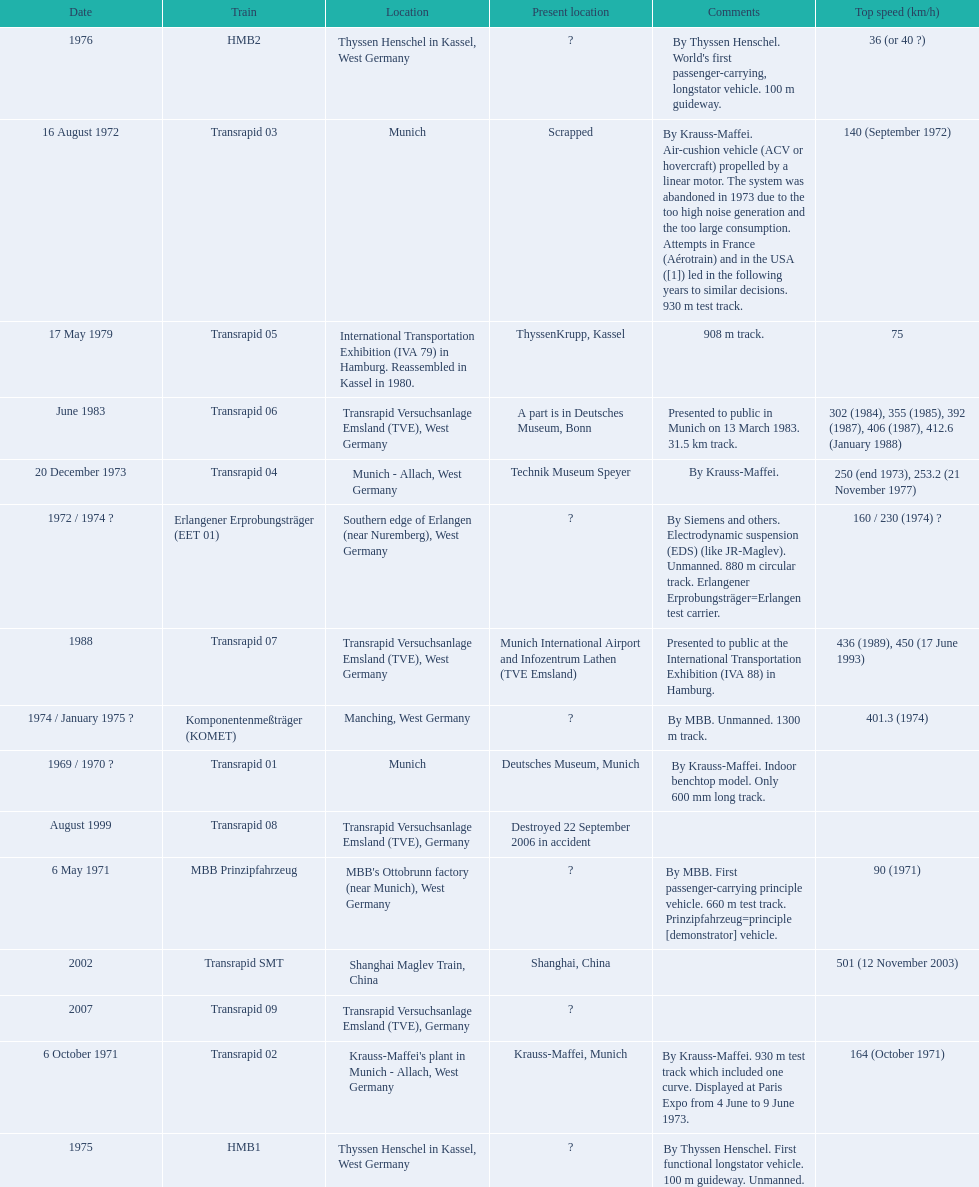What are the names of each transrapid train? Transrapid 01, MBB Prinzipfahrzeug, Transrapid 02, Transrapid 03, Erlangener Erprobungsträger (EET 01), Transrapid 04, Komponentenmeßträger (KOMET), HMB1, HMB2, Transrapid 05, Transrapid 06, Transrapid 07, Transrapid 08, Transrapid SMT, Transrapid 09. What are their listed top speeds? 90 (1971), 164 (October 1971), 140 (September 1972), 160 / 230 (1974) ?, 250 (end 1973), 253.2 (21 November 1977), 401.3 (1974), 36 (or 40 ?), 75, 302 (1984), 355 (1985), 392 (1987), 406 (1987), 412.6 (January 1988), 436 (1989), 450 (17 June 1993), 501 (12 November 2003). And which train operates at the fastest speed? Transrapid SMT. 